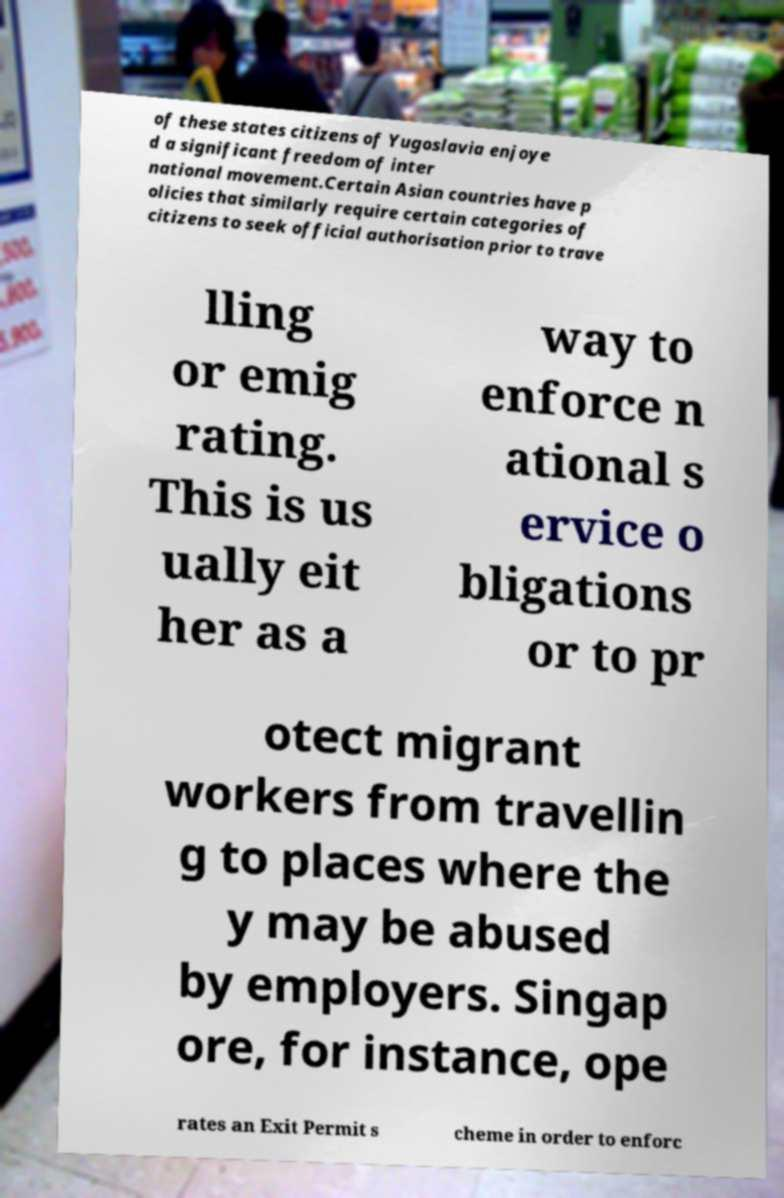For documentation purposes, I need the text within this image transcribed. Could you provide that? of these states citizens of Yugoslavia enjoye d a significant freedom of inter national movement.Certain Asian countries have p olicies that similarly require certain categories of citizens to seek official authorisation prior to trave lling or emig rating. This is us ually eit her as a way to enforce n ational s ervice o bligations or to pr otect migrant workers from travellin g to places where the y may be abused by employers. Singap ore, for instance, ope rates an Exit Permit s cheme in order to enforc 